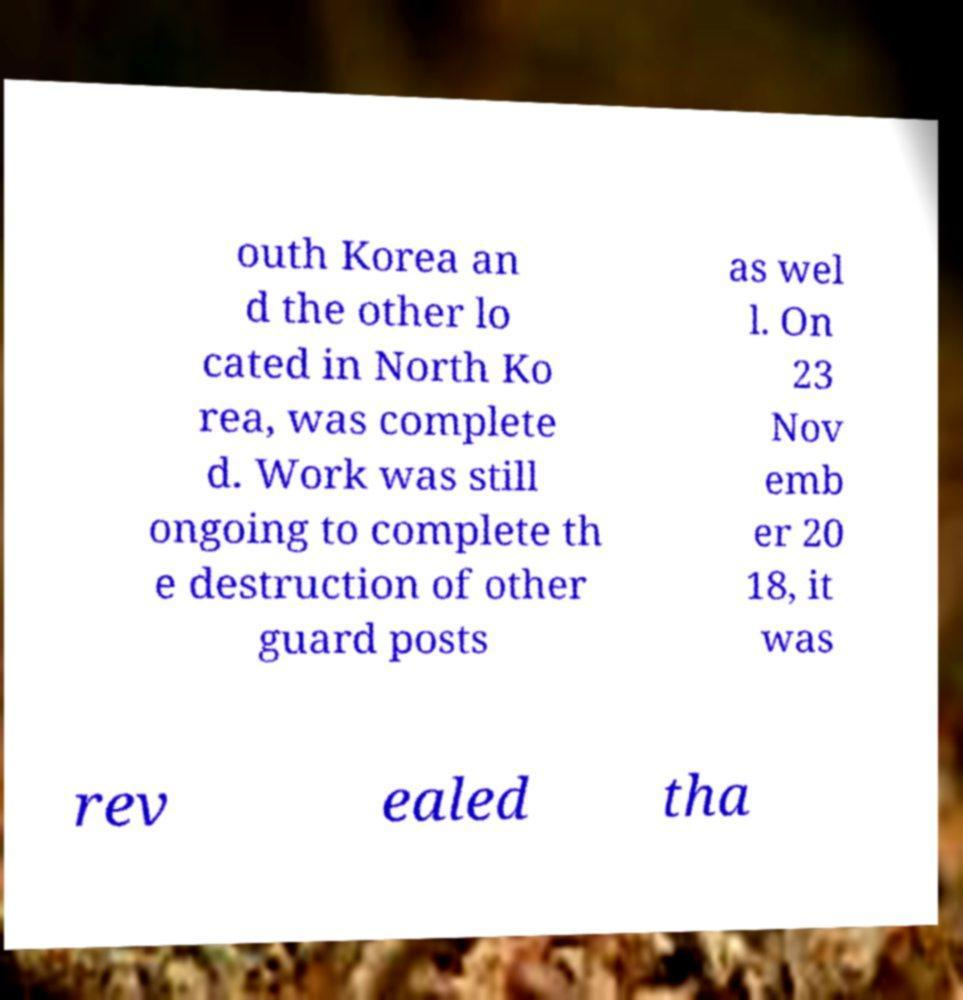There's text embedded in this image that I need extracted. Can you transcribe it verbatim? outh Korea an d the other lo cated in North Ko rea, was complete d. Work was still ongoing to complete th e destruction of other guard posts as wel l. On 23 Nov emb er 20 18, it was rev ealed tha 